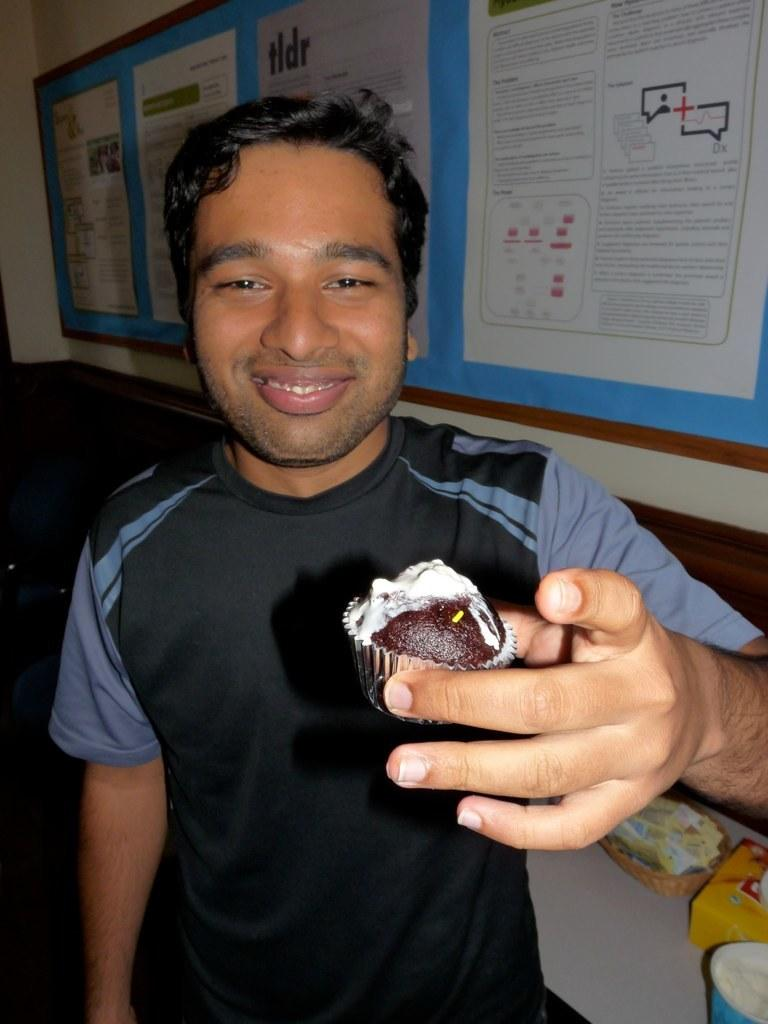Who is present in the image? There is a man in the image. What is the man doing in the image? The man is standing in the image. What is the man holding in his hand? The man is holding a food item in his hand. What is the man wearing in the image? The man is wearing a black t-shirt. How many marks can be seen on the man's feet in the image? There are no marks visible on the man's feet in the image, and there is no mention of any objects touching his feet. 